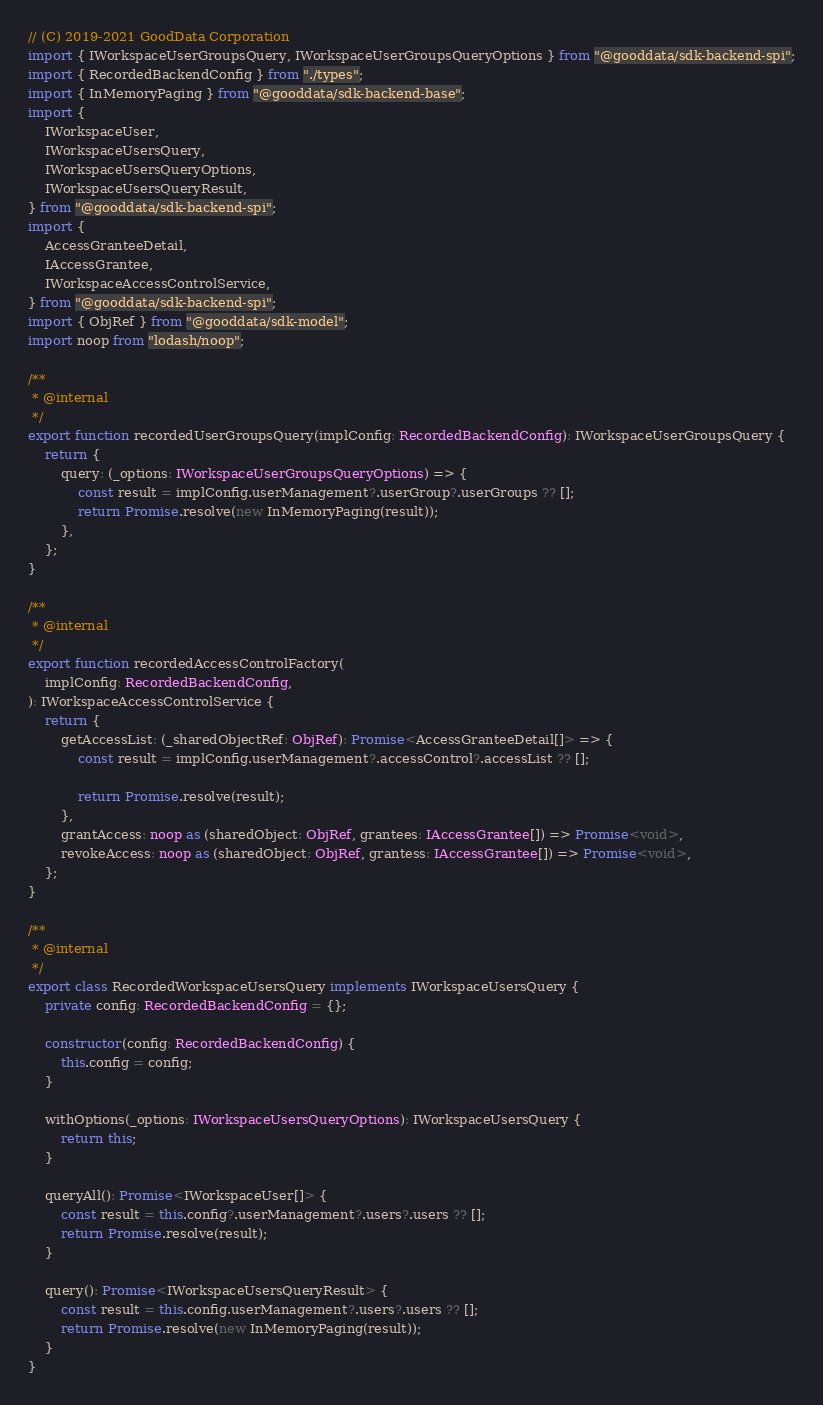Convert code to text. <code><loc_0><loc_0><loc_500><loc_500><_TypeScript_>// (C) 2019-2021 GoodData Corporation
import { IWorkspaceUserGroupsQuery, IWorkspaceUserGroupsQueryOptions } from "@gooddata/sdk-backend-spi";
import { RecordedBackendConfig } from "./types";
import { InMemoryPaging } from "@gooddata/sdk-backend-base";
import {
    IWorkspaceUser,
    IWorkspaceUsersQuery,
    IWorkspaceUsersQueryOptions,
    IWorkspaceUsersQueryResult,
} from "@gooddata/sdk-backend-spi";
import {
    AccessGranteeDetail,
    IAccessGrantee,
    IWorkspaceAccessControlService,
} from "@gooddata/sdk-backend-spi";
import { ObjRef } from "@gooddata/sdk-model";
import noop from "lodash/noop";

/**
 * @internal
 */
export function recordedUserGroupsQuery(implConfig: RecordedBackendConfig): IWorkspaceUserGroupsQuery {
    return {
        query: (_options: IWorkspaceUserGroupsQueryOptions) => {
            const result = implConfig.userManagement?.userGroup?.userGroups ?? [];
            return Promise.resolve(new InMemoryPaging(result));
        },
    };
}

/**
 * @internal
 */
export function recordedAccessControlFactory(
    implConfig: RecordedBackendConfig,
): IWorkspaceAccessControlService {
    return {
        getAccessList: (_sharedObjectRef: ObjRef): Promise<AccessGranteeDetail[]> => {
            const result = implConfig.userManagement?.accessControl?.accessList ?? [];

            return Promise.resolve(result);
        },
        grantAccess: noop as (sharedObject: ObjRef, grantees: IAccessGrantee[]) => Promise<void>,
        revokeAccess: noop as (sharedObject: ObjRef, grantess: IAccessGrantee[]) => Promise<void>,
    };
}

/**
 * @internal
 */
export class RecordedWorkspaceUsersQuery implements IWorkspaceUsersQuery {
    private config: RecordedBackendConfig = {};

    constructor(config: RecordedBackendConfig) {
        this.config = config;
    }

    withOptions(_options: IWorkspaceUsersQueryOptions): IWorkspaceUsersQuery {
        return this;
    }

    queryAll(): Promise<IWorkspaceUser[]> {
        const result = this.config?.userManagement?.users?.users ?? [];
        return Promise.resolve(result);
    }

    query(): Promise<IWorkspaceUsersQueryResult> {
        const result = this.config.userManagement?.users?.users ?? [];
        return Promise.resolve(new InMemoryPaging(result));
    }
}
</code> 